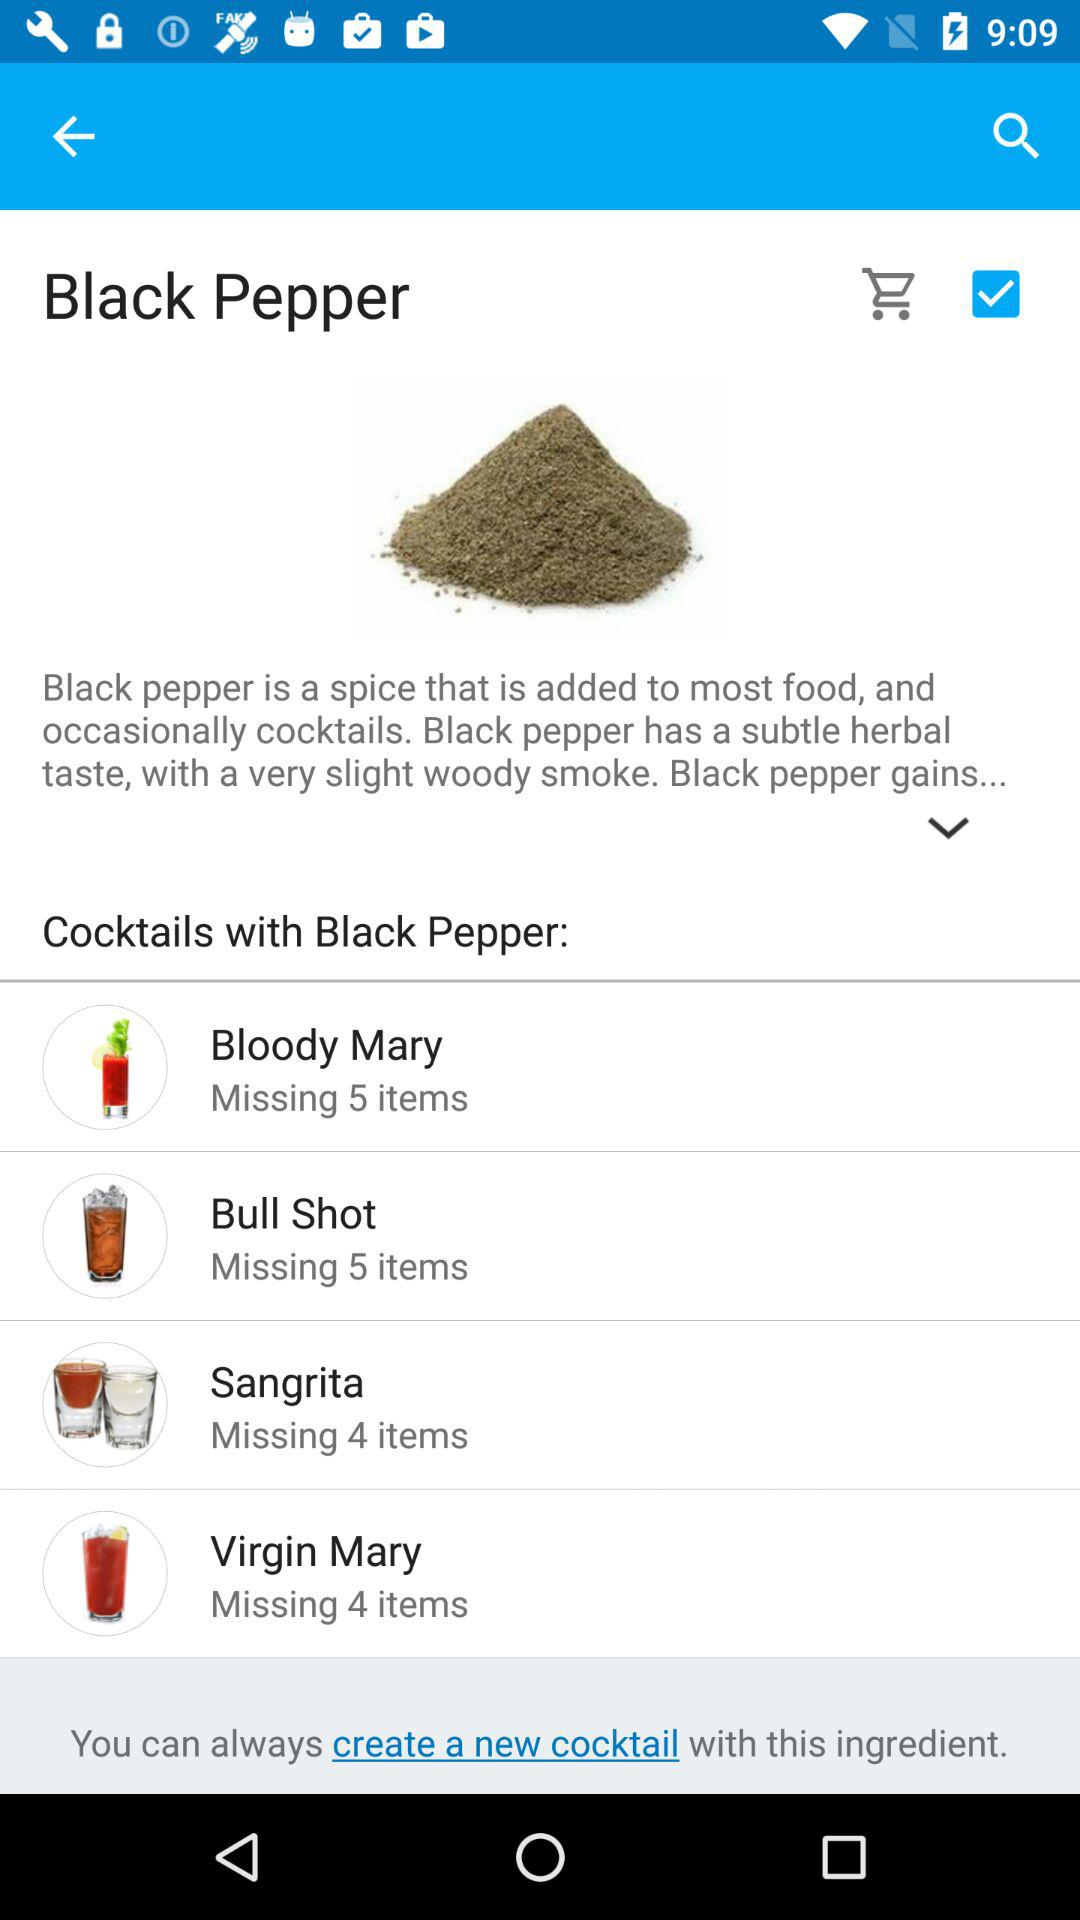How many cocktails contain black pepper?
Answer the question using a single word or phrase. 4 